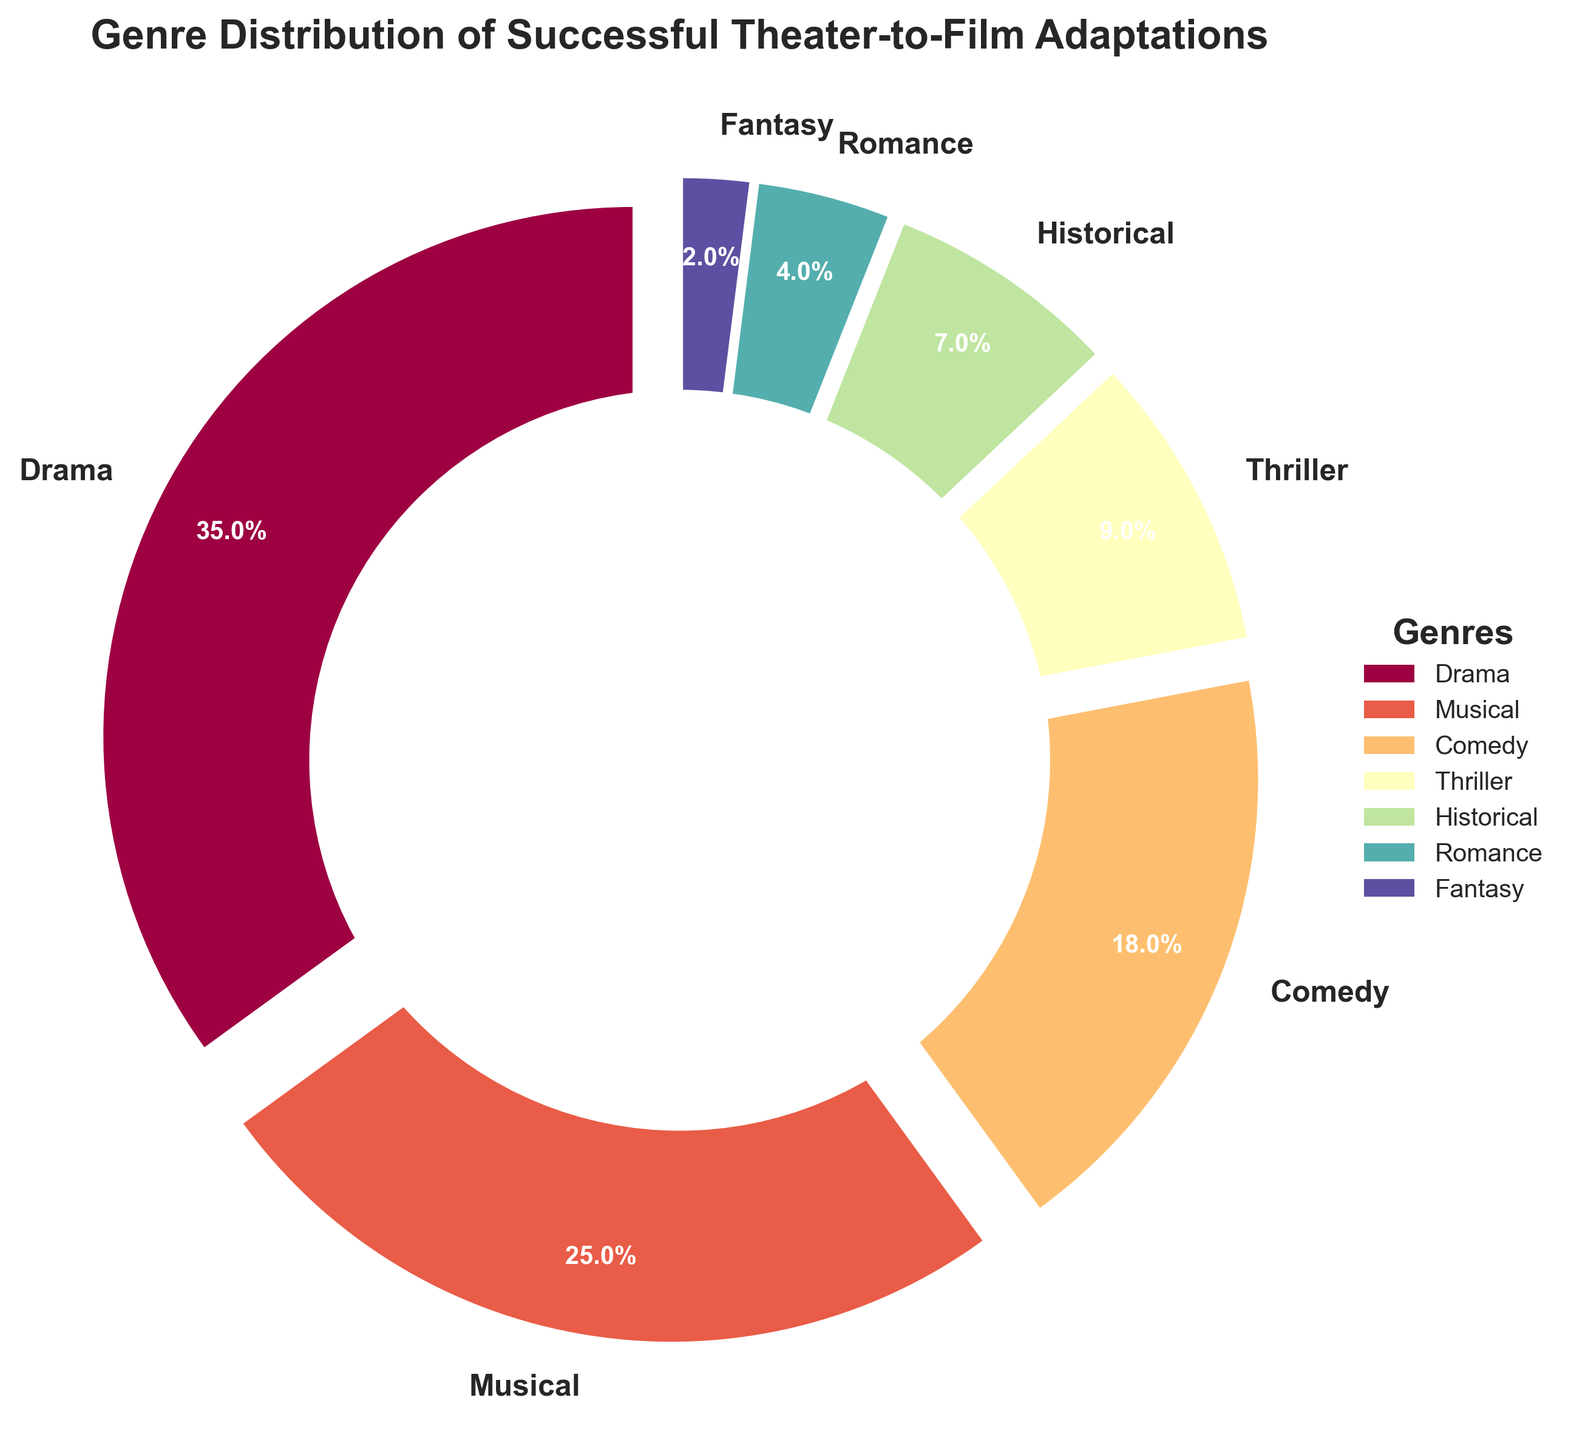Which genre has the highest percentage in the distribution? The genre "Drama" occupies the largest section of the pie chart with 35%
Answer: Drama What is the combined percentage of Comedy and Thriller genres? The percentage for Comedy is 18% and for Thriller is 9%. Adding them gives 18% + 9% = 27%
Answer: 27% Compare the percentage between Musical and Historical genres. Which one is higher and by how much? Musical has 25% while Historical has 7%. Subtracting the percentages 25% - 7% = 18% shows Musical is higher by 18%
Answer: Musical by 18% What is the percentage difference between Romance and Fantasy genres? Romance has 4% and Fantasy has 2%. The difference is 4% - 2% = 2%
Answer: 2% What percentage of the adaptations fall under the Musical and Drama genres combined? Musical has 25% and Drama has 35%. Adding them gives 25% + 35% = 60%
Answer: 60% Identify the genres that together constitute less than 10% each of the total adaptations. Thriller (9%), Historical (7%), Romance (4%), and Fantasy (2%) all have less than 10% each
Answer: Thriller, Historical, Romance, Fantasy If you were to group Romance, Fantasy, and Historical genres together, what percentage of the total adaptations would they represent? Romance is 4%, Fantasy is 2%, and Historical is 7%. Adding them gives 4% + 2% + 7% = 13%
Answer: 13% Is the sum of Musical and Comedy percentages greater than Drama? Musical is 25% and Comedy is 18%. Adding them gives 25% + 18% = 43%. Drama is 35%. Since 43% > 35%, the sum is greater
Answer: Yes, by 8% What is the second most represented genre in the chart? Musical has the second largest section in the pie chart with 25% after Drama.
Answer: Musical 